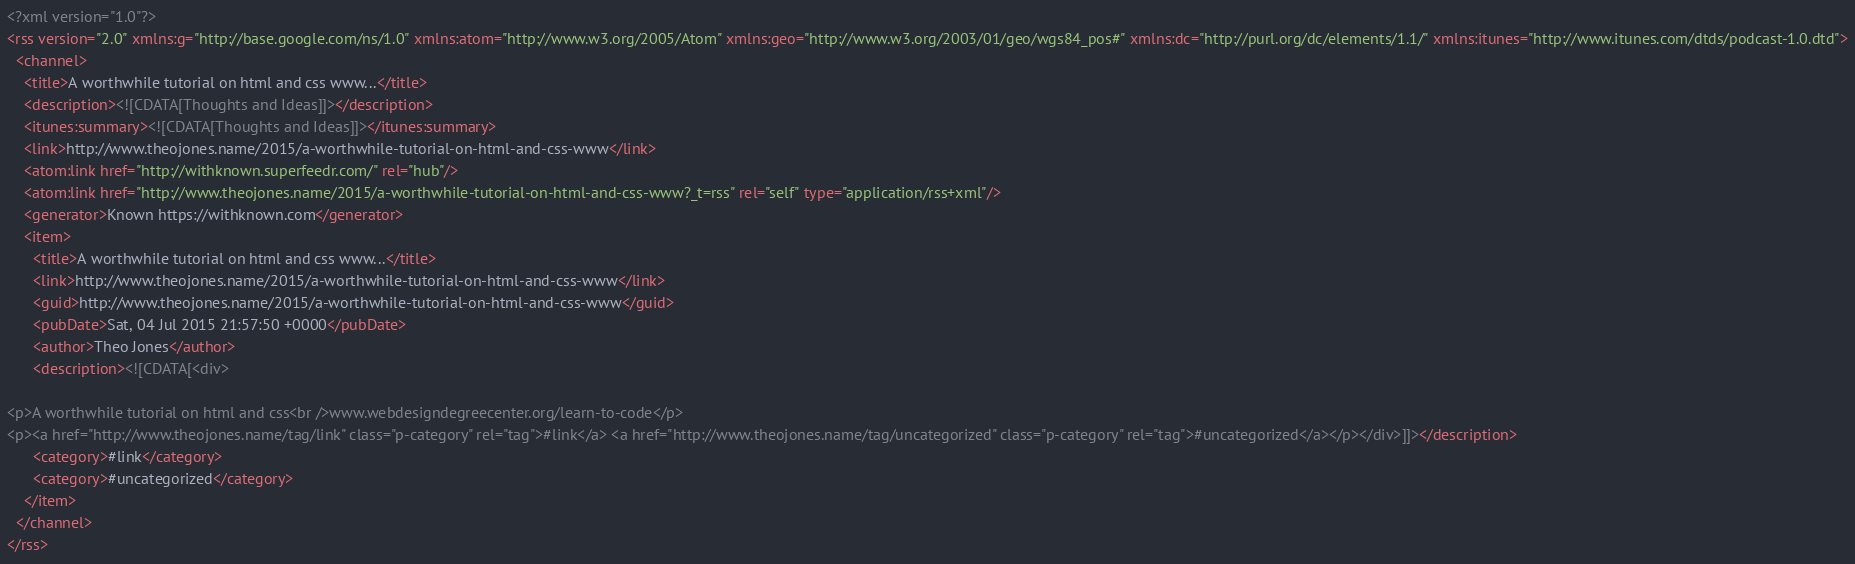Convert code to text. <code><loc_0><loc_0><loc_500><loc_500><_XML_><?xml version="1.0"?>
<rss version="2.0" xmlns:g="http://base.google.com/ns/1.0" xmlns:atom="http://www.w3.org/2005/Atom" xmlns:geo="http://www.w3.org/2003/01/geo/wgs84_pos#" xmlns:dc="http://purl.org/dc/elements/1.1/" xmlns:itunes="http://www.itunes.com/dtds/podcast-1.0.dtd">
  <channel>
    <title>A worthwhile tutorial on html and css www...</title>
    <description><![CDATA[Thoughts and Ideas]]></description>
    <itunes:summary><![CDATA[Thoughts and Ideas]]></itunes:summary>
    <link>http://www.theojones.name/2015/a-worthwhile-tutorial-on-html-and-css-www</link>
    <atom:link href="http://withknown.superfeedr.com/" rel="hub"/>
    <atom:link href="http://www.theojones.name/2015/a-worthwhile-tutorial-on-html-and-css-www?_t=rss" rel="self" type="application/rss+xml"/>
    <generator>Known https://withknown.com</generator>
    <item>
      <title>A worthwhile tutorial on html and css www...</title>
      <link>http://www.theojones.name/2015/a-worthwhile-tutorial-on-html-and-css-www</link>
      <guid>http://www.theojones.name/2015/a-worthwhile-tutorial-on-html-and-css-www</guid>
      <pubDate>Sat, 04 Jul 2015 21:57:50 +0000</pubDate>
      <author>Theo Jones</author>
      <description><![CDATA[<div>
        
<p>A worthwhile tutorial on html and css<br />www.webdesigndegreecenter.org/learn-to-code</p>
<p><a href="http://www.theojones.name/tag/link" class="p-category" rel="tag">#link</a> <a href="http://www.theojones.name/tag/uncategorized" class="p-category" rel="tag">#uncategorized</a></p></div>]]></description>
      <category>#link</category>
      <category>#uncategorized</category>
    </item>
  </channel>
</rss>
</code> 